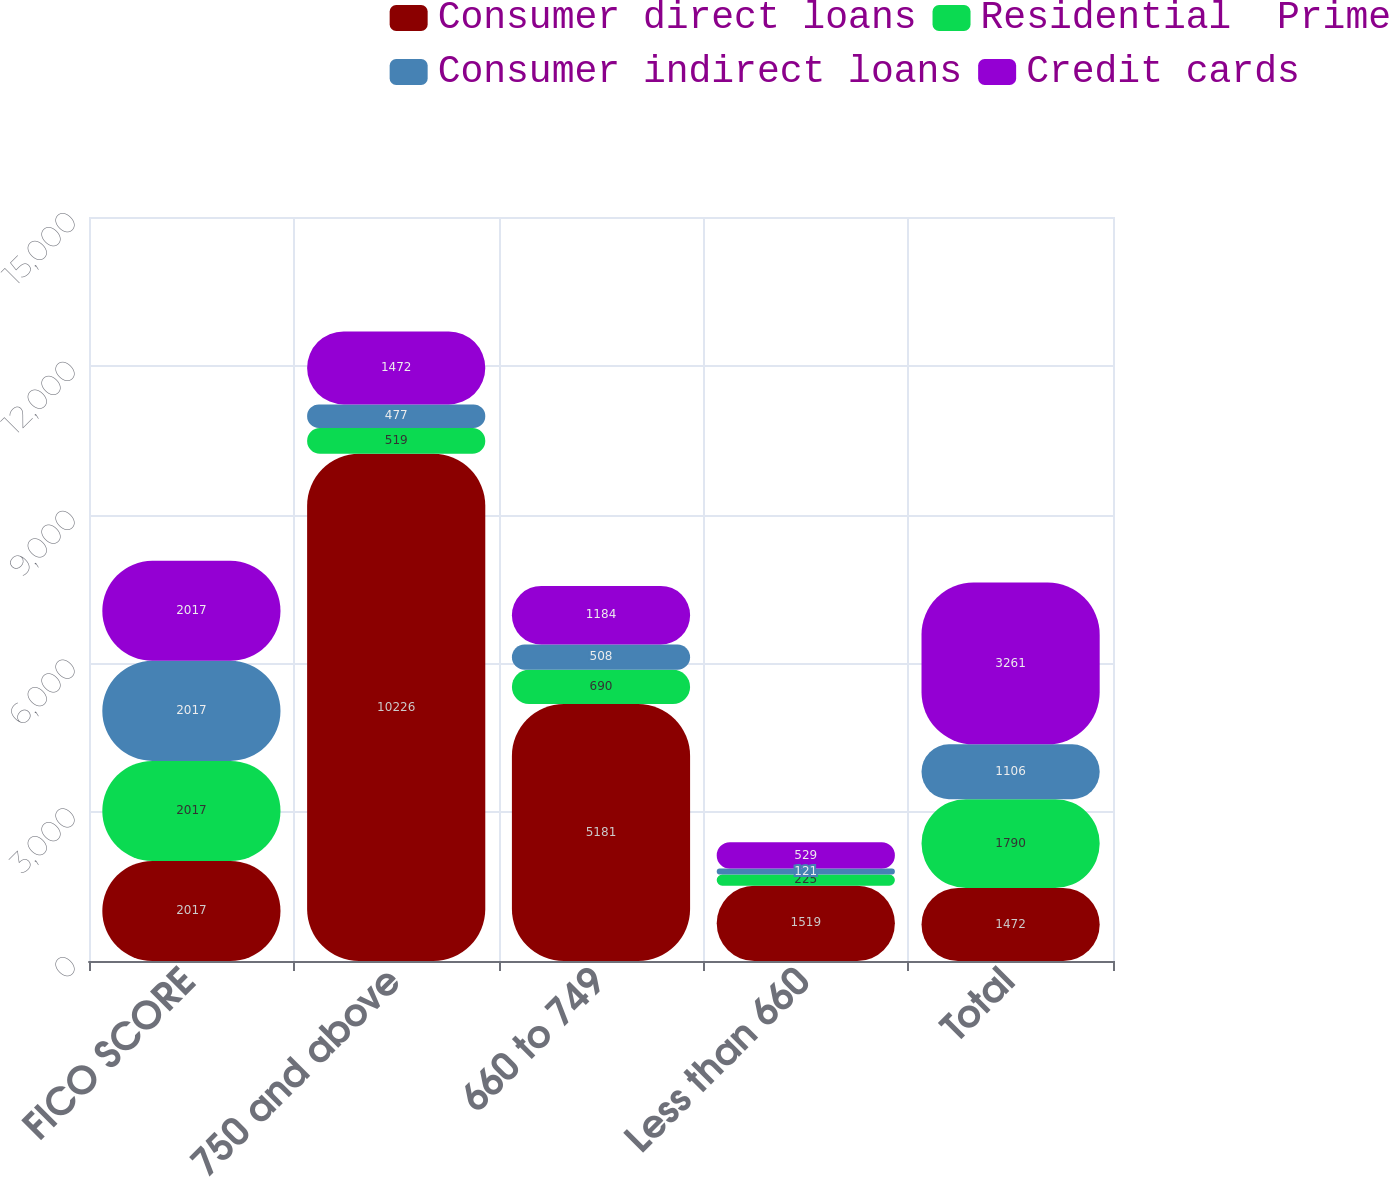Convert chart. <chart><loc_0><loc_0><loc_500><loc_500><stacked_bar_chart><ecel><fcel>FICO SCORE<fcel>750 and above<fcel>660 to 749<fcel>Less than 660<fcel>Total<nl><fcel>Consumer direct loans<fcel>2017<fcel>10226<fcel>5181<fcel>1519<fcel>1472<nl><fcel>Residential  Prime<fcel>2017<fcel>519<fcel>690<fcel>225<fcel>1790<nl><fcel>Consumer indirect loans<fcel>2017<fcel>477<fcel>508<fcel>121<fcel>1106<nl><fcel>Credit cards<fcel>2017<fcel>1472<fcel>1184<fcel>529<fcel>3261<nl></chart> 